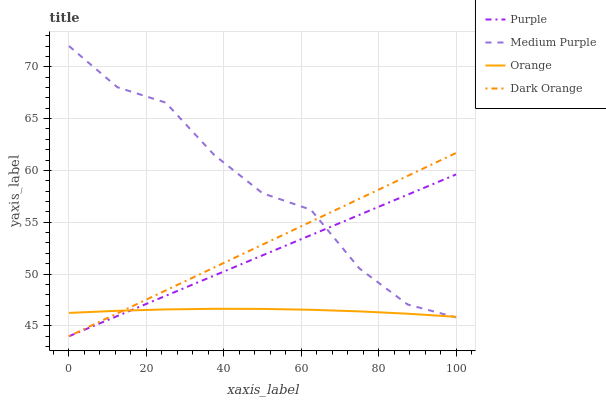Does Orange have the minimum area under the curve?
Answer yes or no. Yes. Does Medium Purple have the maximum area under the curve?
Answer yes or no. Yes. Does Medium Purple have the minimum area under the curve?
Answer yes or no. No. Does Orange have the maximum area under the curve?
Answer yes or no. No. Is Dark Orange the smoothest?
Answer yes or no. Yes. Is Medium Purple the roughest?
Answer yes or no. Yes. Is Orange the smoothest?
Answer yes or no. No. Is Orange the roughest?
Answer yes or no. No. Does Medium Purple have the lowest value?
Answer yes or no. No. Does Orange have the highest value?
Answer yes or no. No. 